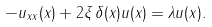<formula> <loc_0><loc_0><loc_500><loc_500>- u _ { x x } ( x ) + 2 \xi \, \delta ( x ) u ( x ) = \lambda u ( x ) .</formula> 